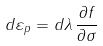<formula> <loc_0><loc_0><loc_500><loc_500>d { \varepsilon } _ { p } = d \lambda \, { \frac { \partial f } { \partial { \sigma } } }</formula> 